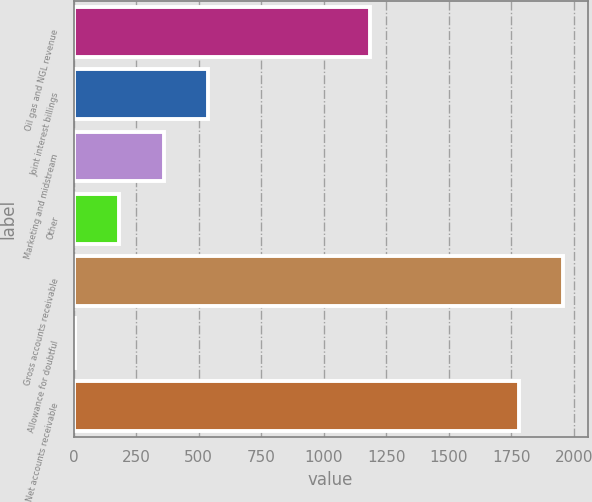Convert chart. <chart><loc_0><loc_0><loc_500><loc_500><bar_chart><fcel>Oil gas and NGL revenue<fcel>Joint interest billings<fcel>Marketing and midstream<fcel>Other<fcel>Gross accounts receivable<fcel>Allowance for doubtful<fcel>Net accounts receivable<nl><fcel>1184<fcel>538.7<fcel>360.8<fcel>182.9<fcel>1956.9<fcel>5<fcel>1779<nl></chart> 